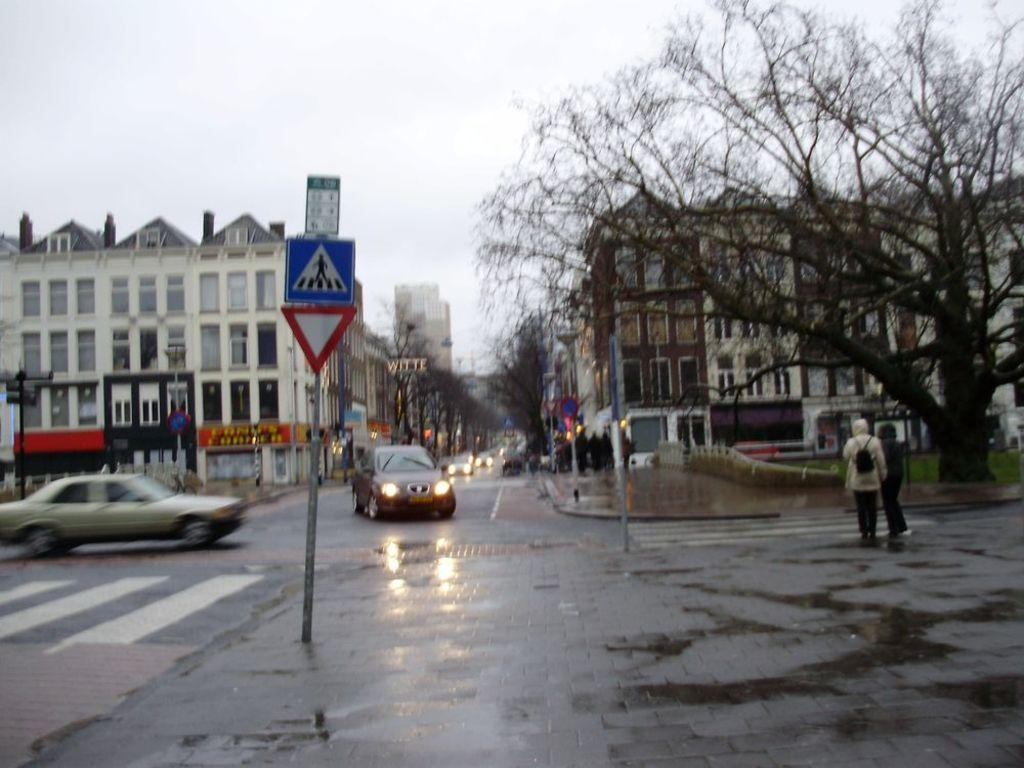What type of vehicles can be seen on the road in the image? There are cars on the road in the image. What natural elements can be seen in the image? There are trees visible in the image. What man-made structures are present in the image? There are signboards and buildings with windows in the image. Are there any living beings visible in the image? Yes, there are people visible in the image. What is visible in the background of the image? The sky is visible in the background of the image. How many birds are sitting on the signboards in the image? There are no birds present on the signboards in the image. What type of ducks can be seen swimming in the water in the image? There is no water or ducks visible in the image. 